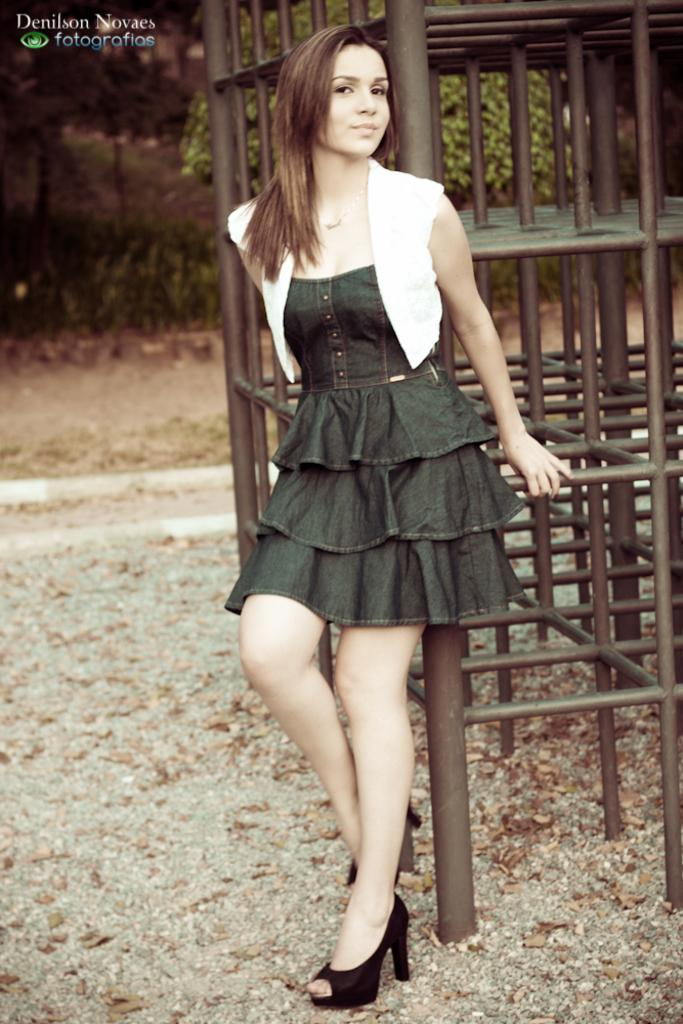What is the main subject of the image? There is a woman standing in the image. Where is the woman standing? The woman is standing on the ground. What can be seen in the background of the image? There is a metal object and a tree in the background of the image. What is present on the ground in the image? There are leaves on the ground in the image. Is there any indication of the image's origin or ownership? Yes, there is a watermark in the image. Can you see the woman falling into the seashore in the image? No, there is no seashore present in the image, and the woman is standing, not falling. What type of brush is the woman using to paint the metal object in the background? There is no brush or painting activity depicted in the image; the woman is simply standing. 